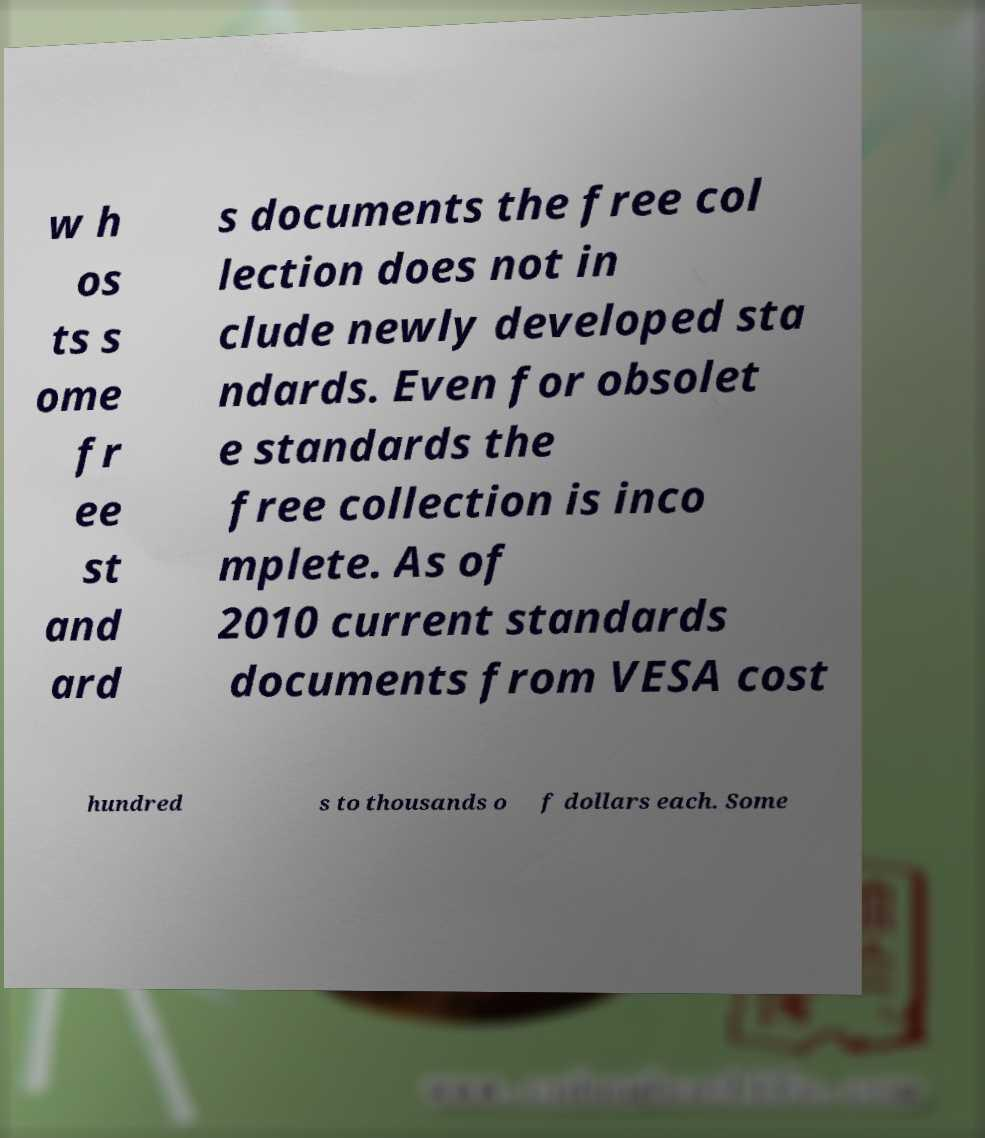Could you assist in decoding the text presented in this image and type it out clearly? w h os ts s ome fr ee st and ard s documents the free col lection does not in clude newly developed sta ndards. Even for obsolet e standards the free collection is inco mplete. As of 2010 current standards documents from VESA cost hundred s to thousands o f dollars each. Some 